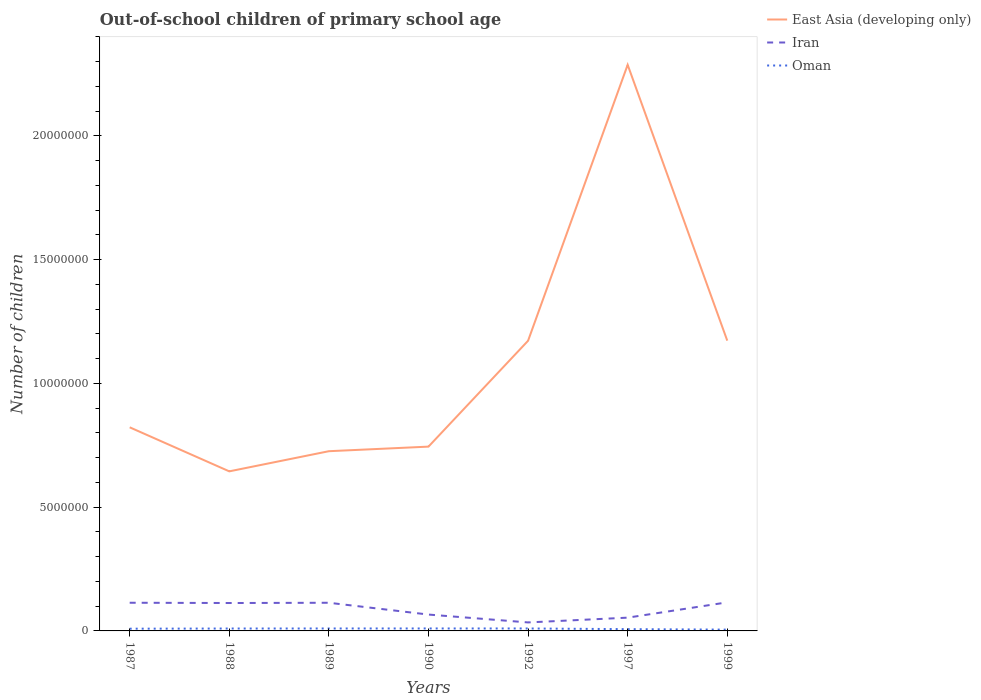Does the line corresponding to Oman intersect with the line corresponding to East Asia (developing only)?
Give a very brief answer. No. Is the number of lines equal to the number of legend labels?
Offer a terse response. Yes. Across all years, what is the maximum number of out-of-school children in Iran?
Make the answer very short. 3.43e+05. What is the total number of out-of-school children in Oman in the graph?
Your answer should be very brief. 2.67e+04. What is the difference between the highest and the second highest number of out-of-school children in East Asia (developing only)?
Offer a very short reply. 1.64e+07. What is the difference between two consecutive major ticks on the Y-axis?
Give a very brief answer. 5.00e+06. Does the graph contain any zero values?
Keep it short and to the point. No. Does the graph contain grids?
Ensure brevity in your answer.  No. What is the title of the graph?
Make the answer very short. Out-of-school children of primary school age. What is the label or title of the X-axis?
Keep it short and to the point. Years. What is the label or title of the Y-axis?
Provide a short and direct response. Number of children. What is the Number of children of East Asia (developing only) in 1987?
Provide a short and direct response. 8.23e+06. What is the Number of children of Iran in 1987?
Make the answer very short. 1.14e+06. What is the Number of children of Oman in 1987?
Offer a terse response. 8.98e+04. What is the Number of children of East Asia (developing only) in 1988?
Offer a very short reply. 6.45e+06. What is the Number of children in Iran in 1988?
Your response must be concise. 1.13e+06. What is the Number of children in Oman in 1988?
Give a very brief answer. 9.69e+04. What is the Number of children in East Asia (developing only) in 1989?
Make the answer very short. 7.26e+06. What is the Number of children of Iran in 1989?
Your answer should be very brief. 1.14e+06. What is the Number of children of Oman in 1989?
Make the answer very short. 9.86e+04. What is the Number of children in East Asia (developing only) in 1990?
Your answer should be very brief. 7.45e+06. What is the Number of children of Iran in 1990?
Give a very brief answer. 6.61e+05. What is the Number of children of Oman in 1990?
Your response must be concise. 9.94e+04. What is the Number of children of East Asia (developing only) in 1992?
Your answer should be compact. 1.17e+07. What is the Number of children of Iran in 1992?
Provide a short and direct response. 3.43e+05. What is the Number of children in Oman in 1992?
Keep it short and to the point. 9.90e+04. What is the Number of children in East Asia (developing only) in 1997?
Make the answer very short. 2.29e+07. What is the Number of children of Iran in 1997?
Offer a terse response. 5.36e+05. What is the Number of children of Oman in 1997?
Ensure brevity in your answer.  7.19e+04. What is the Number of children in East Asia (developing only) in 1999?
Offer a very short reply. 1.17e+07. What is the Number of children in Iran in 1999?
Your response must be concise. 1.15e+06. What is the Number of children of Oman in 1999?
Your answer should be very brief. 5.25e+04. Across all years, what is the maximum Number of children in East Asia (developing only)?
Your answer should be compact. 2.29e+07. Across all years, what is the maximum Number of children of Iran?
Offer a very short reply. 1.15e+06. Across all years, what is the maximum Number of children in Oman?
Provide a succinct answer. 9.94e+04. Across all years, what is the minimum Number of children in East Asia (developing only)?
Provide a succinct answer. 6.45e+06. Across all years, what is the minimum Number of children of Iran?
Provide a short and direct response. 3.43e+05. Across all years, what is the minimum Number of children in Oman?
Offer a very short reply. 5.25e+04. What is the total Number of children of East Asia (developing only) in the graph?
Offer a terse response. 7.57e+07. What is the total Number of children of Iran in the graph?
Ensure brevity in your answer.  6.10e+06. What is the total Number of children of Oman in the graph?
Your answer should be compact. 6.08e+05. What is the difference between the Number of children in East Asia (developing only) in 1987 and that in 1988?
Ensure brevity in your answer.  1.78e+06. What is the difference between the Number of children of Iran in 1987 and that in 1988?
Your answer should be compact. 1.04e+04. What is the difference between the Number of children in Oman in 1987 and that in 1988?
Provide a succinct answer. -7027. What is the difference between the Number of children in East Asia (developing only) in 1987 and that in 1989?
Keep it short and to the point. 9.65e+05. What is the difference between the Number of children of Iran in 1987 and that in 1989?
Provide a succinct answer. 232. What is the difference between the Number of children of Oman in 1987 and that in 1989?
Offer a very short reply. -8758. What is the difference between the Number of children in East Asia (developing only) in 1987 and that in 1990?
Offer a very short reply. 7.80e+05. What is the difference between the Number of children in Iran in 1987 and that in 1990?
Offer a terse response. 4.77e+05. What is the difference between the Number of children in Oman in 1987 and that in 1990?
Give a very brief answer. -9594. What is the difference between the Number of children in East Asia (developing only) in 1987 and that in 1992?
Provide a succinct answer. -3.50e+06. What is the difference between the Number of children of Iran in 1987 and that in 1992?
Ensure brevity in your answer.  7.95e+05. What is the difference between the Number of children in Oman in 1987 and that in 1992?
Your answer should be compact. -9171. What is the difference between the Number of children in East Asia (developing only) in 1987 and that in 1997?
Offer a very short reply. -1.46e+07. What is the difference between the Number of children of Iran in 1987 and that in 1997?
Ensure brevity in your answer.  6.02e+05. What is the difference between the Number of children in Oman in 1987 and that in 1997?
Make the answer very short. 1.80e+04. What is the difference between the Number of children in East Asia (developing only) in 1987 and that in 1999?
Your answer should be very brief. -3.50e+06. What is the difference between the Number of children in Iran in 1987 and that in 1999?
Offer a terse response. -1.65e+04. What is the difference between the Number of children in Oman in 1987 and that in 1999?
Offer a very short reply. 3.74e+04. What is the difference between the Number of children in East Asia (developing only) in 1988 and that in 1989?
Your response must be concise. -8.14e+05. What is the difference between the Number of children in Iran in 1988 and that in 1989?
Your answer should be very brief. -1.02e+04. What is the difference between the Number of children of Oman in 1988 and that in 1989?
Make the answer very short. -1731. What is the difference between the Number of children in East Asia (developing only) in 1988 and that in 1990?
Your answer should be very brief. -9.98e+05. What is the difference between the Number of children of Iran in 1988 and that in 1990?
Ensure brevity in your answer.  4.66e+05. What is the difference between the Number of children of Oman in 1988 and that in 1990?
Your answer should be very brief. -2567. What is the difference between the Number of children of East Asia (developing only) in 1988 and that in 1992?
Provide a succinct answer. -5.28e+06. What is the difference between the Number of children of Iran in 1988 and that in 1992?
Make the answer very short. 7.84e+05. What is the difference between the Number of children in Oman in 1988 and that in 1992?
Offer a terse response. -2144. What is the difference between the Number of children of East Asia (developing only) in 1988 and that in 1997?
Your answer should be very brief. -1.64e+07. What is the difference between the Number of children of Iran in 1988 and that in 1997?
Ensure brevity in your answer.  5.91e+05. What is the difference between the Number of children in Oman in 1988 and that in 1997?
Offer a very short reply. 2.50e+04. What is the difference between the Number of children of East Asia (developing only) in 1988 and that in 1999?
Your response must be concise. -5.28e+06. What is the difference between the Number of children in Iran in 1988 and that in 1999?
Ensure brevity in your answer.  -2.69e+04. What is the difference between the Number of children of Oman in 1988 and that in 1999?
Your response must be concise. 4.44e+04. What is the difference between the Number of children of East Asia (developing only) in 1989 and that in 1990?
Offer a very short reply. -1.85e+05. What is the difference between the Number of children of Iran in 1989 and that in 1990?
Make the answer very short. 4.77e+05. What is the difference between the Number of children in Oman in 1989 and that in 1990?
Make the answer very short. -836. What is the difference between the Number of children in East Asia (developing only) in 1989 and that in 1992?
Ensure brevity in your answer.  -4.46e+06. What is the difference between the Number of children of Iran in 1989 and that in 1992?
Your response must be concise. 7.95e+05. What is the difference between the Number of children of Oman in 1989 and that in 1992?
Offer a terse response. -413. What is the difference between the Number of children in East Asia (developing only) in 1989 and that in 1997?
Your answer should be very brief. -1.56e+07. What is the difference between the Number of children in Iran in 1989 and that in 1997?
Offer a terse response. 6.02e+05. What is the difference between the Number of children in Oman in 1989 and that in 1997?
Offer a very short reply. 2.67e+04. What is the difference between the Number of children of East Asia (developing only) in 1989 and that in 1999?
Provide a short and direct response. -4.47e+06. What is the difference between the Number of children of Iran in 1989 and that in 1999?
Keep it short and to the point. -1.67e+04. What is the difference between the Number of children in Oman in 1989 and that in 1999?
Provide a short and direct response. 4.61e+04. What is the difference between the Number of children of East Asia (developing only) in 1990 and that in 1992?
Your answer should be compact. -4.28e+06. What is the difference between the Number of children in Iran in 1990 and that in 1992?
Make the answer very short. 3.18e+05. What is the difference between the Number of children in Oman in 1990 and that in 1992?
Ensure brevity in your answer.  423. What is the difference between the Number of children of East Asia (developing only) in 1990 and that in 1997?
Ensure brevity in your answer.  -1.54e+07. What is the difference between the Number of children of Iran in 1990 and that in 1997?
Provide a succinct answer. 1.25e+05. What is the difference between the Number of children of Oman in 1990 and that in 1997?
Your response must be concise. 2.76e+04. What is the difference between the Number of children of East Asia (developing only) in 1990 and that in 1999?
Your answer should be compact. -4.28e+06. What is the difference between the Number of children of Iran in 1990 and that in 1999?
Provide a short and direct response. -4.93e+05. What is the difference between the Number of children in Oman in 1990 and that in 1999?
Give a very brief answer. 4.69e+04. What is the difference between the Number of children of East Asia (developing only) in 1992 and that in 1997?
Offer a terse response. -1.11e+07. What is the difference between the Number of children in Iran in 1992 and that in 1997?
Your answer should be compact. -1.93e+05. What is the difference between the Number of children of Oman in 1992 and that in 1997?
Offer a terse response. 2.71e+04. What is the difference between the Number of children of East Asia (developing only) in 1992 and that in 1999?
Offer a very short reply. -4097. What is the difference between the Number of children in Iran in 1992 and that in 1999?
Your response must be concise. -8.11e+05. What is the difference between the Number of children of Oman in 1992 and that in 1999?
Offer a terse response. 4.65e+04. What is the difference between the Number of children of East Asia (developing only) in 1997 and that in 1999?
Keep it short and to the point. 1.11e+07. What is the difference between the Number of children in Iran in 1997 and that in 1999?
Provide a short and direct response. -6.18e+05. What is the difference between the Number of children of Oman in 1997 and that in 1999?
Keep it short and to the point. 1.94e+04. What is the difference between the Number of children of East Asia (developing only) in 1987 and the Number of children of Iran in 1988?
Keep it short and to the point. 7.10e+06. What is the difference between the Number of children of East Asia (developing only) in 1987 and the Number of children of Oman in 1988?
Your answer should be compact. 8.13e+06. What is the difference between the Number of children in Iran in 1987 and the Number of children in Oman in 1988?
Your answer should be compact. 1.04e+06. What is the difference between the Number of children of East Asia (developing only) in 1987 and the Number of children of Iran in 1989?
Offer a terse response. 7.09e+06. What is the difference between the Number of children in East Asia (developing only) in 1987 and the Number of children in Oman in 1989?
Ensure brevity in your answer.  8.13e+06. What is the difference between the Number of children of Iran in 1987 and the Number of children of Oman in 1989?
Offer a very short reply. 1.04e+06. What is the difference between the Number of children in East Asia (developing only) in 1987 and the Number of children in Iran in 1990?
Give a very brief answer. 7.56e+06. What is the difference between the Number of children of East Asia (developing only) in 1987 and the Number of children of Oman in 1990?
Your response must be concise. 8.13e+06. What is the difference between the Number of children of Iran in 1987 and the Number of children of Oman in 1990?
Offer a very short reply. 1.04e+06. What is the difference between the Number of children of East Asia (developing only) in 1987 and the Number of children of Iran in 1992?
Your answer should be compact. 7.88e+06. What is the difference between the Number of children in East Asia (developing only) in 1987 and the Number of children in Oman in 1992?
Your response must be concise. 8.13e+06. What is the difference between the Number of children of Iran in 1987 and the Number of children of Oman in 1992?
Provide a succinct answer. 1.04e+06. What is the difference between the Number of children of East Asia (developing only) in 1987 and the Number of children of Iran in 1997?
Keep it short and to the point. 7.69e+06. What is the difference between the Number of children of East Asia (developing only) in 1987 and the Number of children of Oman in 1997?
Your response must be concise. 8.15e+06. What is the difference between the Number of children in Iran in 1987 and the Number of children in Oman in 1997?
Provide a short and direct response. 1.07e+06. What is the difference between the Number of children in East Asia (developing only) in 1987 and the Number of children in Iran in 1999?
Ensure brevity in your answer.  7.07e+06. What is the difference between the Number of children of East Asia (developing only) in 1987 and the Number of children of Oman in 1999?
Keep it short and to the point. 8.17e+06. What is the difference between the Number of children of Iran in 1987 and the Number of children of Oman in 1999?
Give a very brief answer. 1.09e+06. What is the difference between the Number of children in East Asia (developing only) in 1988 and the Number of children in Iran in 1989?
Your answer should be compact. 5.31e+06. What is the difference between the Number of children in East Asia (developing only) in 1988 and the Number of children in Oman in 1989?
Offer a terse response. 6.35e+06. What is the difference between the Number of children of Iran in 1988 and the Number of children of Oman in 1989?
Keep it short and to the point. 1.03e+06. What is the difference between the Number of children of East Asia (developing only) in 1988 and the Number of children of Iran in 1990?
Offer a terse response. 5.79e+06. What is the difference between the Number of children of East Asia (developing only) in 1988 and the Number of children of Oman in 1990?
Ensure brevity in your answer.  6.35e+06. What is the difference between the Number of children of Iran in 1988 and the Number of children of Oman in 1990?
Provide a short and direct response. 1.03e+06. What is the difference between the Number of children of East Asia (developing only) in 1988 and the Number of children of Iran in 1992?
Make the answer very short. 6.10e+06. What is the difference between the Number of children of East Asia (developing only) in 1988 and the Number of children of Oman in 1992?
Make the answer very short. 6.35e+06. What is the difference between the Number of children of Iran in 1988 and the Number of children of Oman in 1992?
Ensure brevity in your answer.  1.03e+06. What is the difference between the Number of children in East Asia (developing only) in 1988 and the Number of children in Iran in 1997?
Provide a succinct answer. 5.91e+06. What is the difference between the Number of children of East Asia (developing only) in 1988 and the Number of children of Oman in 1997?
Give a very brief answer. 6.37e+06. What is the difference between the Number of children in Iran in 1988 and the Number of children in Oman in 1997?
Give a very brief answer. 1.06e+06. What is the difference between the Number of children of East Asia (developing only) in 1988 and the Number of children of Iran in 1999?
Your answer should be very brief. 5.29e+06. What is the difference between the Number of children in East Asia (developing only) in 1988 and the Number of children in Oman in 1999?
Offer a terse response. 6.39e+06. What is the difference between the Number of children of Iran in 1988 and the Number of children of Oman in 1999?
Your answer should be very brief. 1.07e+06. What is the difference between the Number of children of East Asia (developing only) in 1989 and the Number of children of Iran in 1990?
Keep it short and to the point. 6.60e+06. What is the difference between the Number of children of East Asia (developing only) in 1989 and the Number of children of Oman in 1990?
Make the answer very short. 7.16e+06. What is the difference between the Number of children of Iran in 1989 and the Number of children of Oman in 1990?
Keep it short and to the point. 1.04e+06. What is the difference between the Number of children in East Asia (developing only) in 1989 and the Number of children in Iran in 1992?
Make the answer very short. 6.92e+06. What is the difference between the Number of children of East Asia (developing only) in 1989 and the Number of children of Oman in 1992?
Your answer should be very brief. 7.16e+06. What is the difference between the Number of children of Iran in 1989 and the Number of children of Oman in 1992?
Your answer should be compact. 1.04e+06. What is the difference between the Number of children of East Asia (developing only) in 1989 and the Number of children of Iran in 1997?
Your answer should be very brief. 6.72e+06. What is the difference between the Number of children in East Asia (developing only) in 1989 and the Number of children in Oman in 1997?
Make the answer very short. 7.19e+06. What is the difference between the Number of children in Iran in 1989 and the Number of children in Oman in 1997?
Your response must be concise. 1.07e+06. What is the difference between the Number of children of East Asia (developing only) in 1989 and the Number of children of Iran in 1999?
Provide a short and direct response. 6.11e+06. What is the difference between the Number of children of East Asia (developing only) in 1989 and the Number of children of Oman in 1999?
Offer a terse response. 7.21e+06. What is the difference between the Number of children of Iran in 1989 and the Number of children of Oman in 1999?
Offer a very short reply. 1.09e+06. What is the difference between the Number of children in East Asia (developing only) in 1990 and the Number of children in Iran in 1992?
Your answer should be very brief. 7.10e+06. What is the difference between the Number of children of East Asia (developing only) in 1990 and the Number of children of Oman in 1992?
Provide a short and direct response. 7.35e+06. What is the difference between the Number of children in Iran in 1990 and the Number of children in Oman in 1992?
Offer a very short reply. 5.62e+05. What is the difference between the Number of children in East Asia (developing only) in 1990 and the Number of children in Iran in 1997?
Ensure brevity in your answer.  6.91e+06. What is the difference between the Number of children in East Asia (developing only) in 1990 and the Number of children in Oman in 1997?
Your answer should be very brief. 7.37e+06. What is the difference between the Number of children in Iran in 1990 and the Number of children in Oman in 1997?
Your answer should be very brief. 5.89e+05. What is the difference between the Number of children of East Asia (developing only) in 1990 and the Number of children of Iran in 1999?
Offer a terse response. 6.29e+06. What is the difference between the Number of children of East Asia (developing only) in 1990 and the Number of children of Oman in 1999?
Provide a succinct answer. 7.39e+06. What is the difference between the Number of children in Iran in 1990 and the Number of children in Oman in 1999?
Offer a terse response. 6.09e+05. What is the difference between the Number of children in East Asia (developing only) in 1992 and the Number of children in Iran in 1997?
Your answer should be compact. 1.12e+07. What is the difference between the Number of children of East Asia (developing only) in 1992 and the Number of children of Oman in 1997?
Provide a short and direct response. 1.17e+07. What is the difference between the Number of children of Iran in 1992 and the Number of children of Oman in 1997?
Provide a succinct answer. 2.71e+05. What is the difference between the Number of children in East Asia (developing only) in 1992 and the Number of children in Iran in 1999?
Offer a very short reply. 1.06e+07. What is the difference between the Number of children of East Asia (developing only) in 1992 and the Number of children of Oman in 1999?
Offer a very short reply. 1.17e+07. What is the difference between the Number of children in Iran in 1992 and the Number of children in Oman in 1999?
Keep it short and to the point. 2.91e+05. What is the difference between the Number of children in East Asia (developing only) in 1997 and the Number of children in Iran in 1999?
Provide a short and direct response. 2.17e+07. What is the difference between the Number of children of East Asia (developing only) in 1997 and the Number of children of Oman in 1999?
Your answer should be compact. 2.28e+07. What is the difference between the Number of children in Iran in 1997 and the Number of children in Oman in 1999?
Offer a terse response. 4.84e+05. What is the average Number of children of East Asia (developing only) per year?
Your response must be concise. 1.08e+07. What is the average Number of children in Iran per year?
Ensure brevity in your answer.  8.71e+05. What is the average Number of children of Oman per year?
Offer a very short reply. 8.69e+04. In the year 1987, what is the difference between the Number of children in East Asia (developing only) and Number of children in Iran?
Ensure brevity in your answer.  7.09e+06. In the year 1987, what is the difference between the Number of children of East Asia (developing only) and Number of children of Oman?
Ensure brevity in your answer.  8.14e+06. In the year 1987, what is the difference between the Number of children of Iran and Number of children of Oman?
Your answer should be very brief. 1.05e+06. In the year 1988, what is the difference between the Number of children in East Asia (developing only) and Number of children in Iran?
Offer a terse response. 5.32e+06. In the year 1988, what is the difference between the Number of children of East Asia (developing only) and Number of children of Oman?
Your response must be concise. 6.35e+06. In the year 1988, what is the difference between the Number of children in Iran and Number of children in Oman?
Offer a terse response. 1.03e+06. In the year 1989, what is the difference between the Number of children of East Asia (developing only) and Number of children of Iran?
Give a very brief answer. 6.12e+06. In the year 1989, what is the difference between the Number of children in East Asia (developing only) and Number of children in Oman?
Your response must be concise. 7.16e+06. In the year 1989, what is the difference between the Number of children in Iran and Number of children in Oman?
Your answer should be very brief. 1.04e+06. In the year 1990, what is the difference between the Number of children of East Asia (developing only) and Number of children of Iran?
Provide a succinct answer. 6.78e+06. In the year 1990, what is the difference between the Number of children in East Asia (developing only) and Number of children in Oman?
Your response must be concise. 7.35e+06. In the year 1990, what is the difference between the Number of children in Iran and Number of children in Oman?
Provide a short and direct response. 5.62e+05. In the year 1992, what is the difference between the Number of children of East Asia (developing only) and Number of children of Iran?
Ensure brevity in your answer.  1.14e+07. In the year 1992, what is the difference between the Number of children in East Asia (developing only) and Number of children in Oman?
Your answer should be very brief. 1.16e+07. In the year 1992, what is the difference between the Number of children in Iran and Number of children in Oman?
Make the answer very short. 2.44e+05. In the year 1997, what is the difference between the Number of children of East Asia (developing only) and Number of children of Iran?
Offer a very short reply. 2.23e+07. In the year 1997, what is the difference between the Number of children in East Asia (developing only) and Number of children in Oman?
Offer a terse response. 2.28e+07. In the year 1997, what is the difference between the Number of children of Iran and Number of children of Oman?
Your answer should be compact. 4.64e+05. In the year 1999, what is the difference between the Number of children in East Asia (developing only) and Number of children in Iran?
Provide a short and direct response. 1.06e+07. In the year 1999, what is the difference between the Number of children in East Asia (developing only) and Number of children in Oman?
Offer a terse response. 1.17e+07. In the year 1999, what is the difference between the Number of children in Iran and Number of children in Oman?
Your answer should be compact. 1.10e+06. What is the ratio of the Number of children in East Asia (developing only) in 1987 to that in 1988?
Your response must be concise. 1.28. What is the ratio of the Number of children of Iran in 1987 to that in 1988?
Your response must be concise. 1.01. What is the ratio of the Number of children in Oman in 1987 to that in 1988?
Provide a succinct answer. 0.93. What is the ratio of the Number of children of East Asia (developing only) in 1987 to that in 1989?
Your answer should be very brief. 1.13. What is the ratio of the Number of children in Oman in 1987 to that in 1989?
Offer a terse response. 0.91. What is the ratio of the Number of children of East Asia (developing only) in 1987 to that in 1990?
Give a very brief answer. 1.1. What is the ratio of the Number of children of Iran in 1987 to that in 1990?
Provide a short and direct response. 1.72. What is the ratio of the Number of children of Oman in 1987 to that in 1990?
Ensure brevity in your answer.  0.9. What is the ratio of the Number of children in East Asia (developing only) in 1987 to that in 1992?
Your answer should be compact. 0.7. What is the ratio of the Number of children of Iran in 1987 to that in 1992?
Offer a terse response. 3.32. What is the ratio of the Number of children in Oman in 1987 to that in 1992?
Ensure brevity in your answer.  0.91. What is the ratio of the Number of children in East Asia (developing only) in 1987 to that in 1997?
Offer a terse response. 0.36. What is the ratio of the Number of children in Iran in 1987 to that in 1997?
Your response must be concise. 2.12. What is the ratio of the Number of children in Oman in 1987 to that in 1997?
Ensure brevity in your answer.  1.25. What is the ratio of the Number of children of East Asia (developing only) in 1987 to that in 1999?
Make the answer very short. 0.7. What is the ratio of the Number of children of Iran in 1987 to that in 1999?
Ensure brevity in your answer.  0.99. What is the ratio of the Number of children in Oman in 1987 to that in 1999?
Provide a short and direct response. 1.71. What is the ratio of the Number of children of East Asia (developing only) in 1988 to that in 1989?
Provide a succinct answer. 0.89. What is the ratio of the Number of children in Iran in 1988 to that in 1989?
Offer a very short reply. 0.99. What is the ratio of the Number of children of Oman in 1988 to that in 1989?
Make the answer very short. 0.98. What is the ratio of the Number of children in East Asia (developing only) in 1988 to that in 1990?
Offer a very short reply. 0.87. What is the ratio of the Number of children in Iran in 1988 to that in 1990?
Offer a very short reply. 1.71. What is the ratio of the Number of children of Oman in 1988 to that in 1990?
Your answer should be very brief. 0.97. What is the ratio of the Number of children of East Asia (developing only) in 1988 to that in 1992?
Give a very brief answer. 0.55. What is the ratio of the Number of children of Iran in 1988 to that in 1992?
Offer a very short reply. 3.29. What is the ratio of the Number of children in Oman in 1988 to that in 1992?
Make the answer very short. 0.98. What is the ratio of the Number of children in East Asia (developing only) in 1988 to that in 1997?
Make the answer very short. 0.28. What is the ratio of the Number of children of Iran in 1988 to that in 1997?
Provide a succinct answer. 2.1. What is the ratio of the Number of children in Oman in 1988 to that in 1997?
Provide a succinct answer. 1.35. What is the ratio of the Number of children of East Asia (developing only) in 1988 to that in 1999?
Keep it short and to the point. 0.55. What is the ratio of the Number of children in Iran in 1988 to that in 1999?
Your answer should be compact. 0.98. What is the ratio of the Number of children of Oman in 1988 to that in 1999?
Your answer should be compact. 1.85. What is the ratio of the Number of children of East Asia (developing only) in 1989 to that in 1990?
Your answer should be compact. 0.98. What is the ratio of the Number of children in Iran in 1989 to that in 1990?
Provide a short and direct response. 1.72. What is the ratio of the Number of children of Oman in 1989 to that in 1990?
Keep it short and to the point. 0.99. What is the ratio of the Number of children of East Asia (developing only) in 1989 to that in 1992?
Your answer should be very brief. 0.62. What is the ratio of the Number of children in Iran in 1989 to that in 1992?
Provide a succinct answer. 3.32. What is the ratio of the Number of children of Oman in 1989 to that in 1992?
Provide a short and direct response. 1. What is the ratio of the Number of children in East Asia (developing only) in 1989 to that in 1997?
Give a very brief answer. 0.32. What is the ratio of the Number of children of Iran in 1989 to that in 1997?
Your response must be concise. 2.12. What is the ratio of the Number of children of Oman in 1989 to that in 1997?
Your answer should be very brief. 1.37. What is the ratio of the Number of children of East Asia (developing only) in 1989 to that in 1999?
Provide a short and direct response. 0.62. What is the ratio of the Number of children in Iran in 1989 to that in 1999?
Make the answer very short. 0.99. What is the ratio of the Number of children in Oman in 1989 to that in 1999?
Offer a terse response. 1.88. What is the ratio of the Number of children in East Asia (developing only) in 1990 to that in 1992?
Your answer should be compact. 0.64. What is the ratio of the Number of children of Iran in 1990 to that in 1992?
Provide a short and direct response. 1.93. What is the ratio of the Number of children in East Asia (developing only) in 1990 to that in 1997?
Ensure brevity in your answer.  0.33. What is the ratio of the Number of children of Iran in 1990 to that in 1997?
Offer a terse response. 1.23. What is the ratio of the Number of children in Oman in 1990 to that in 1997?
Your response must be concise. 1.38. What is the ratio of the Number of children of East Asia (developing only) in 1990 to that in 1999?
Your answer should be very brief. 0.63. What is the ratio of the Number of children in Iran in 1990 to that in 1999?
Provide a short and direct response. 0.57. What is the ratio of the Number of children in Oman in 1990 to that in 1999?
Offer a terse response. 1.89. What is the ratio of the Number of children of East Asia (developing only) in 1992 to that in 1997?
Ensure brevity in your answer.  0.51. What is the ratio of the Number of children of Iran in 1992 to that in 1997?
Offer a terse response. 0.64. What is the ratio of the Number of children in Oman in 1992 to that in 1997?
Provide a succinct answer. 1.38. What is the ratio of the Number of children of East Asia (developing only) in 1992 to that in 1999?
Provide a succinct answer. 1. What is the ratio of the Number of children of Iran in 1992 to that in 1999?
Offer a very short reply. 0.3. What is the ratio of the Number of children of Oman in 1992 to that in 1999?
Provide a succinct answer. 1.89. What is the ratio of the Number of children of East Asia (developing only) in 1997 to that in 1999?
Ensure brevity in your answer.  1.95. What is the ratio of the Number of children in Iran in 1997 to that in 1999?
Offer a terse response. 0.46. What is the ratio of the Number of children of Oman in 1997 to that in 1999?
Offer a terse response. 1.37. What is the difference between the highest and the second highest Number of children of East Asia (developing only)?
Provide a short and direct response. 1.11e+07. What is the difference between the highest and the second highest Number of children in Iran?
Make the answer very short. 1.65e+04. What is the difference between the highest and the second highest Number of children of Oman?
Make the answer very short. 423. What is the difference between the highest and the lowest Number of children in East Asia (developing only)?
Ensure brevity in your answer.  1.64e+07. What is the difference between the highest and the lowest Number of children of Iran?
Give a very brief answer. 8.11e+05. What is the difference between the highest and the lowest Number of children in Oman?
Ensure brevity in your answer.  4.69e+04. 